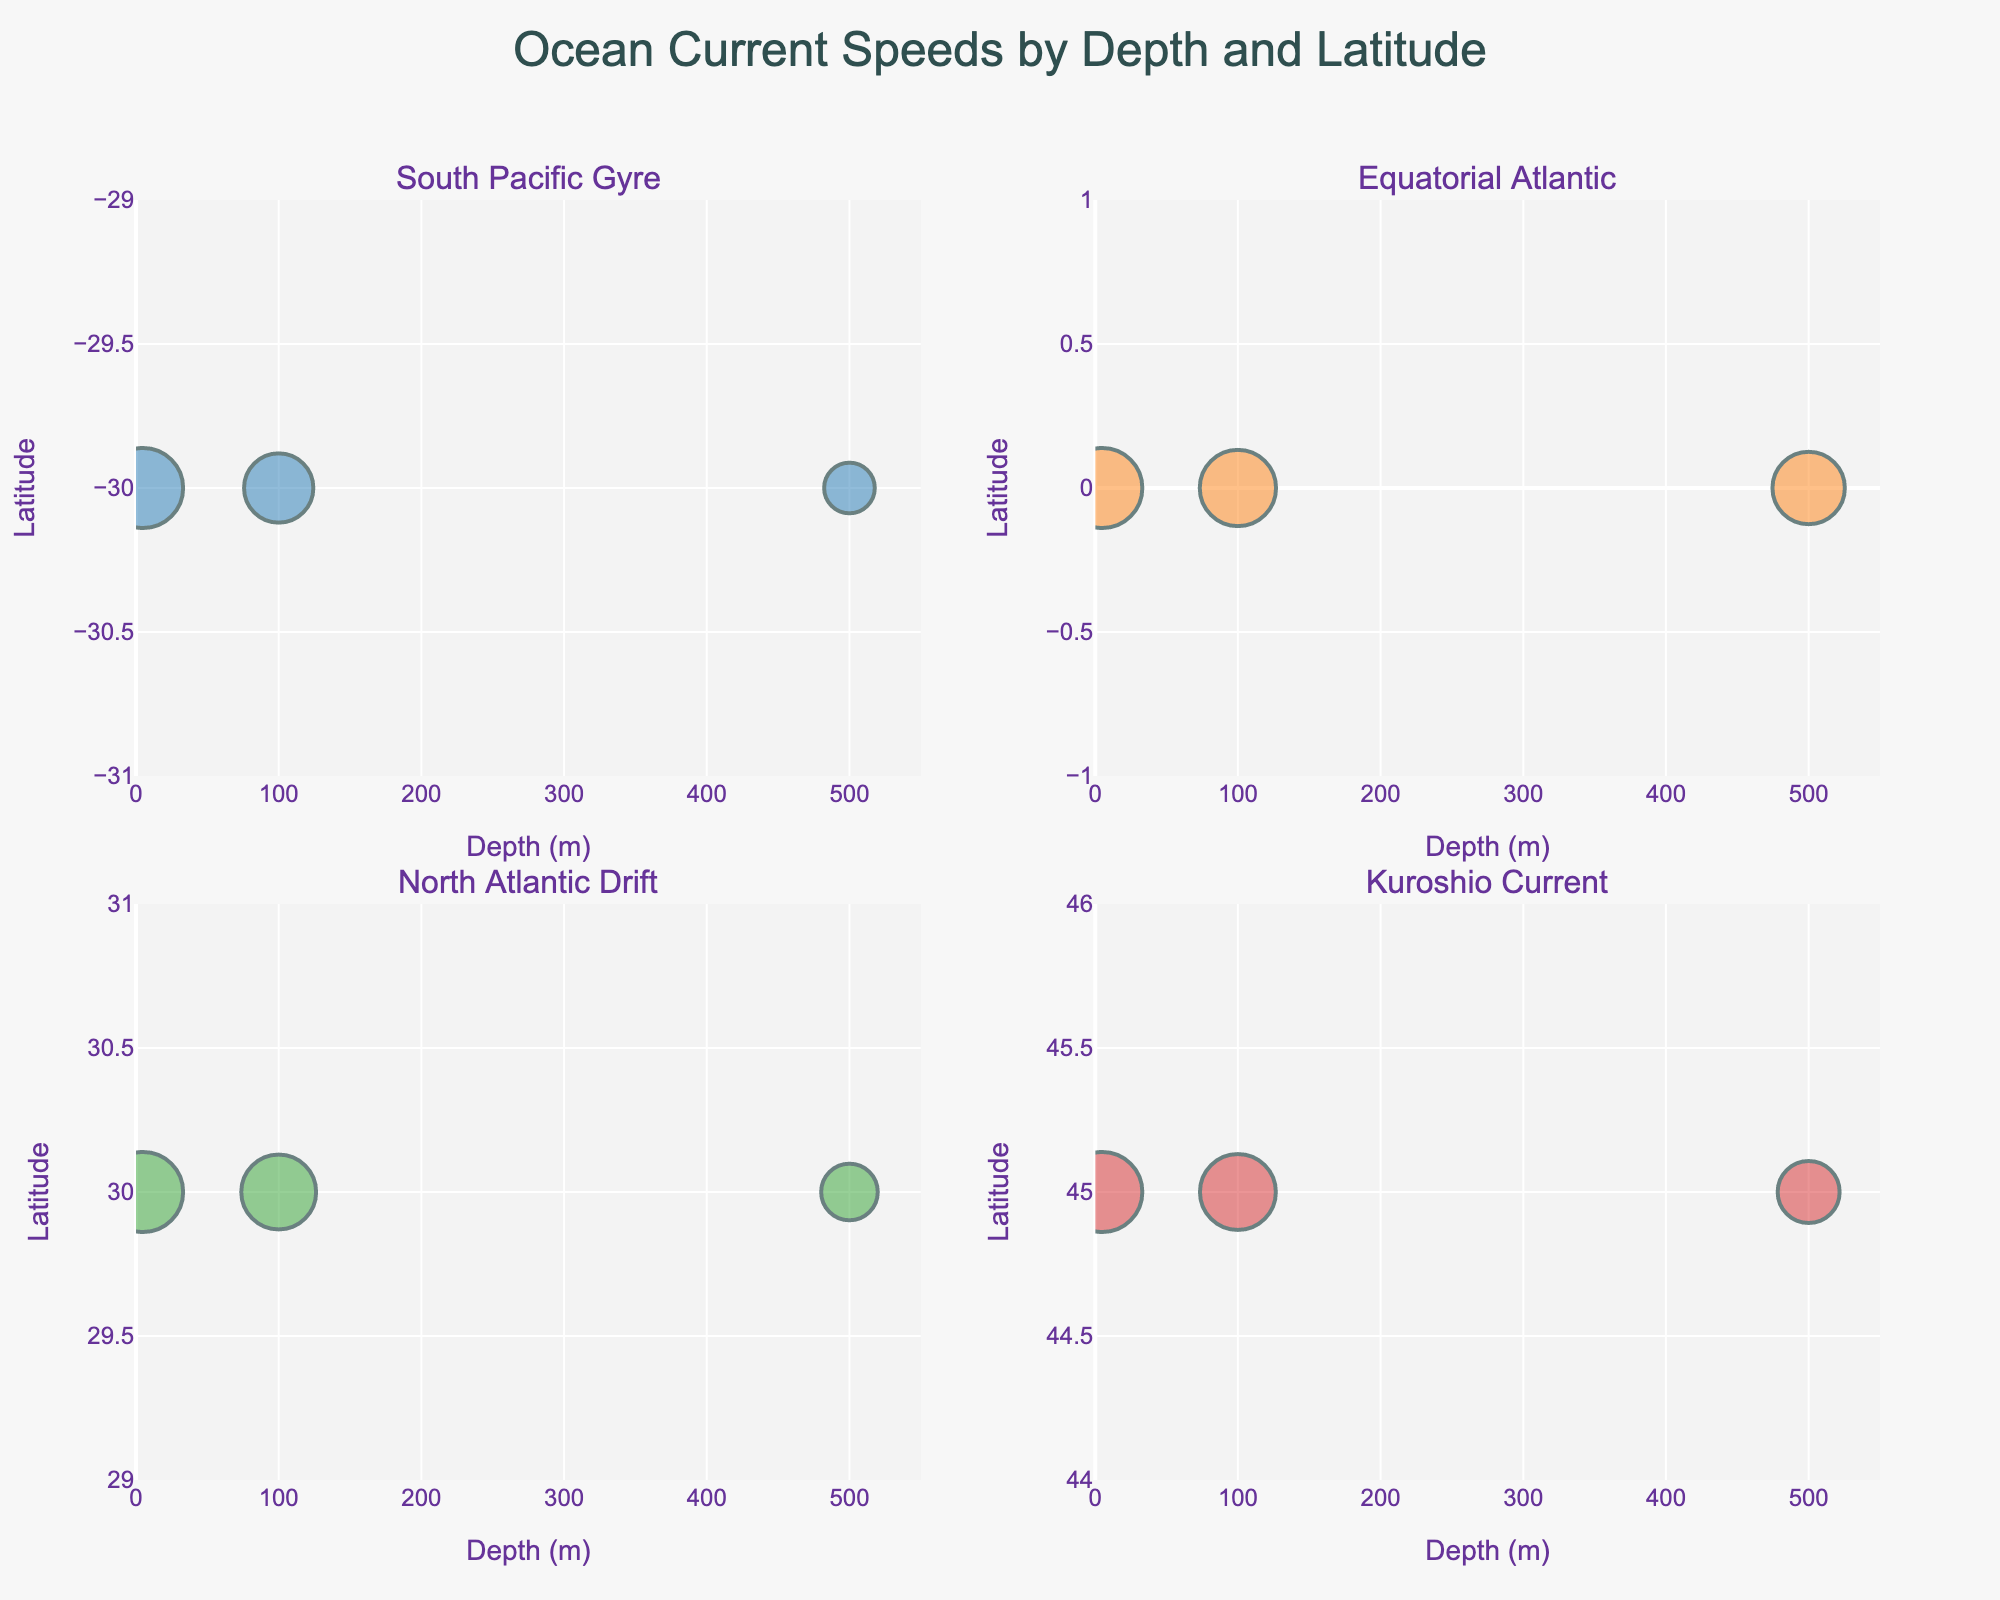What's the title of the figure? The title of the figure is usually located at the top center of the plot. In this case, it is mentioned in the code that the title text is "Ocean Current Speeds by Depth and Latitude".
Answer: Ocean Current Speeds by Depth and Latitude How many subplots are there in the figure? There are 4 subplot titles specified in the code for the figure creation: "South Pacific Gyre", "Equatorial Atlantic", "North Atlantic Drift", and "Kuroshio Current". Therefore, we can see there are 4 subplots.
Answer: 4 Which ocean current has the highest measured surface speed? For each subplot, we can observe the size of bubbles at Depth=5. The subplot titled "Equatorial Atlantic" has the largest bubble indicating a surface speed of 1.1 m/s.
Answer: Equatorial Atlantic What is the depth range for all locations? All subplots show depths on the x-axis with a range from 0 to 550 meters, as defined by the x-axis update code.
Answer: 0 to 550 meters Between the "Kuroshio Current" and "North Atlantic Drift", which has a higher current speed at 100 meters depth? By comparing the bubbles at Depth=100 for both subplots, "Kuroshio Current" has a larger bubble at this depth, indicating a higher speed which is 0.45 m/s compared to 0.35 m/s for "North Atlantic Drift".
Answer: Kuroshio Current Which current, out of the four subplots, shows the least variability in current speed across depths? To determine variability, we look at the differences in bubble sizes within each subplot. The "South Pacific Gyre" shows the least variability since the sizes of bubbles across different depths (5m, 100m, 500m) are more consistent compared to other subplots.
Answer: South Pacific Gyre What is the average current speed at 500 meters depth across all locations? Summing the speeds at 500m depth: 0.08 (South Pacific Gyre) + 0.9 (Equatorial Atlantic) + 0.2 (North Atlantic Drift) + 0.3 (Kuroshio Current) = 1.48. Dividing by the number of locations (4) gives the average: 1.48/4 = 0.37 m/s.
Answer: 0.37 m/s Which subplot contains a location that has its lowest current speed at the shallowest depth measured (5 meters)? By evaluating each subplot, "South Pacific Gyre" shows the smallest bubble at 5m with a speed of 0.2 m/s, which is its lowest value compared to other depths in this subplot.
Answer: South Pacific Gyre For the "Equatorial Atlantic", how does the current speed change from 100 meters to 500 meters depth? Within the "Equatorial Atlantic" subplot, the bubble size decreases from Depth=100 (1.0 m/s) to Depth=500 (0.9 m/s), indicating a slight decrease in current speed.
Answer: Decreases Which latitude marks the location of the "Kuroshio Current"? Examining the y-axes labels of the subplot titled "Kuroshio Current", the latitude is consistent at 45 degrees.
Answer: 45 degrees 